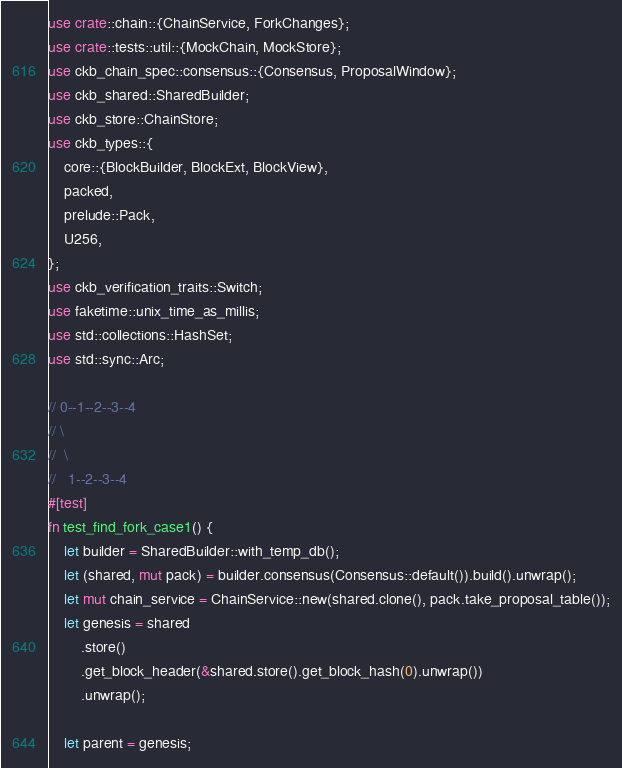Convert code to text. <code><loc_0><loc_0><loc_500><loc_500><_Rust_>use crate::chain::{ChainService, ForkChanges};
use crate::tests::util::{MockChain, MockStore};
use ckb_chain_spec::consensus::{Consensus, ProposalWindow};
use ckb_shared::SharedBuilder;
use ckb_store::ChainStore;
use ckb_types::{
    core::{BlockBuilder, BlockExt, BlockView},
    packed,
    prelude::Pack,
    U256,
};
use ckb_verification_traits::Switch;
use faketime::unix_time_as_millis;
use std::collections::HashSet;
use std::sync::Arc;

// 0--1--2--3--4
// \
//  \
//   1--2--3--4
#[test]
fn test_find_fork_case1() {
    let builder = SharedBuilder::with_temp_db();
    let (shared, mut pack) = builder.consensus(Consensus::default()).build().unwrap();
    let mut chain_service = ChainService::new(shared.clone(), pack.take_proposal_table());
    let genesis = shared
        .store()
        .get_block_header(&shared.store().get_block_hash(0).unwrap())
        .unwrap();

    let parent = genesis;</code> 